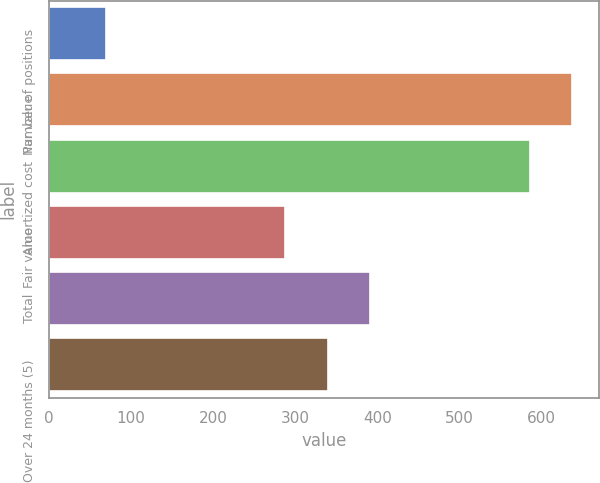Convert chart. <chart><loc_0><loc_0><loc_500><loc_500><bar_chart><fcel>Number of positions<fcel>Par value<fcel>Amortized cost<fcel>Fair value<fcel>Total<fcel>Over 24 months (5)<nl><fcel>70<fcel>637.7<fcel>586<fcel>288<fcel>391.4<fcel>339.7<nl></chart> 